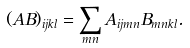Convert formula to latex. <formula><loc_0><loc_0><loc_500><loc_500>( A B ) _ { i j k l } = \sum _ { m n } A _ { i j m n } B _ { m n k l } .</formula> 